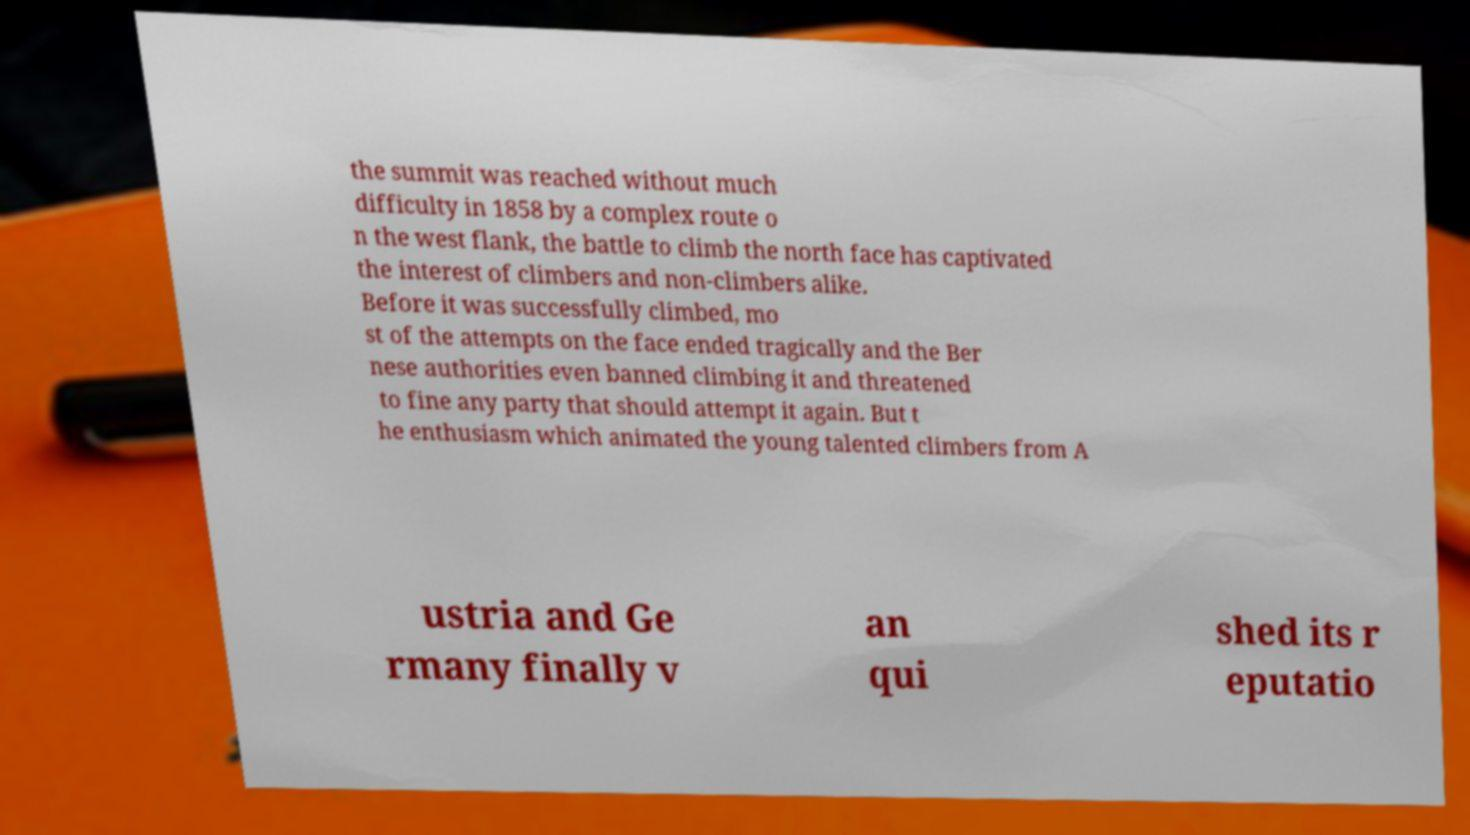Can you accurately transcribe the text from the provided image for me? the summit was reached without much difficulty in 1858 by a complex route o n the west flank, the battle to climb the north face has captivated the interest of climbers and non-climbers alike. Before it was successfully climbed, mo st of the attempts on the face ended tragically and the Ber nese authorities even banned climbing it and threatened to fine any party that should attempt it again. But t he enthusiasm which animated the young talented climbers from A ustria and Ge rmany finally v an qui shed its r eputatio 